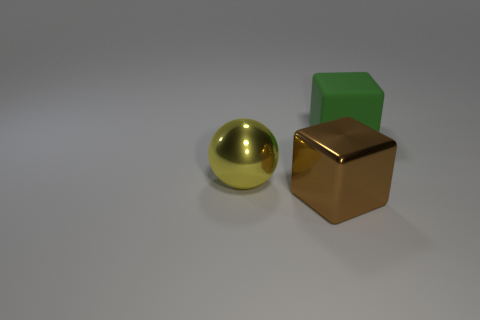What number of brown things have the same material as the brown cube?
Give a very brief answer. 0. Is the shape of the matte object the same as the brown metal thing?
Keep it short and to the point. Yes. There is a cube that is to the right of the block that is in front of the block that is behind the brown thing; what is its size?
Give a very brief answer. Large. There is a big brown metallic block that is right of the yellow metallic thing; is there a large green cube that is to the left of it?
Provide a short and direct response. No. There is a large cube that is on the right side of the big block on the left side of the green rubber object; what number of things are in front of it?
Provide a succinct answer. 2. What color is the thing that is behind the brown shiny block and right of the metal ball?
Offer a very short reply. Green. How many objects have the same color as the rubber cube?
Ensure brevity in your answer.  0. What number of cubes are either brown objects or rubber objects?
Your response must be concise. 2. There is a metallic block that is the same size as the shiny sphere; what color is it?
Keep it short and to the point. Brown. There is a cube that is behind the big block in front of the matte thing; are there any big yellow spheres in front of it?
Offer a terse response. Yes. 